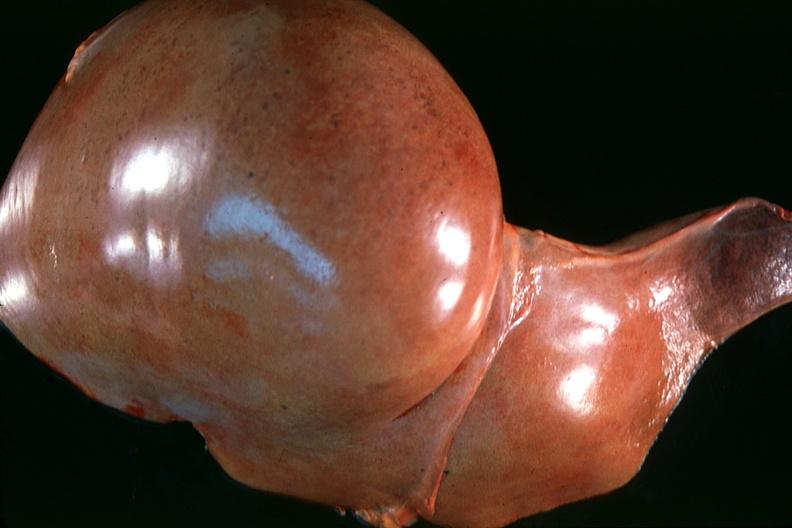s anencephaly and bilateral cleft palate present?
Answer the question using a single word or phrase. No 